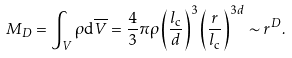<formula> <loc_0><loc_0><loc_500><loc_500>M _ { D } = \int _ { V } \rho { \mathrm d } \overline { V } = \frac { 4 } { 3 } \pi \rho \left ( \frac { l _ { \mathrm c } } { d } \right ) ^ { 3 } \left ( \frac { r } { l _ { \mathrm c } } \right ) ^ { 3 d } \sim r ^ { D } .</formula> 